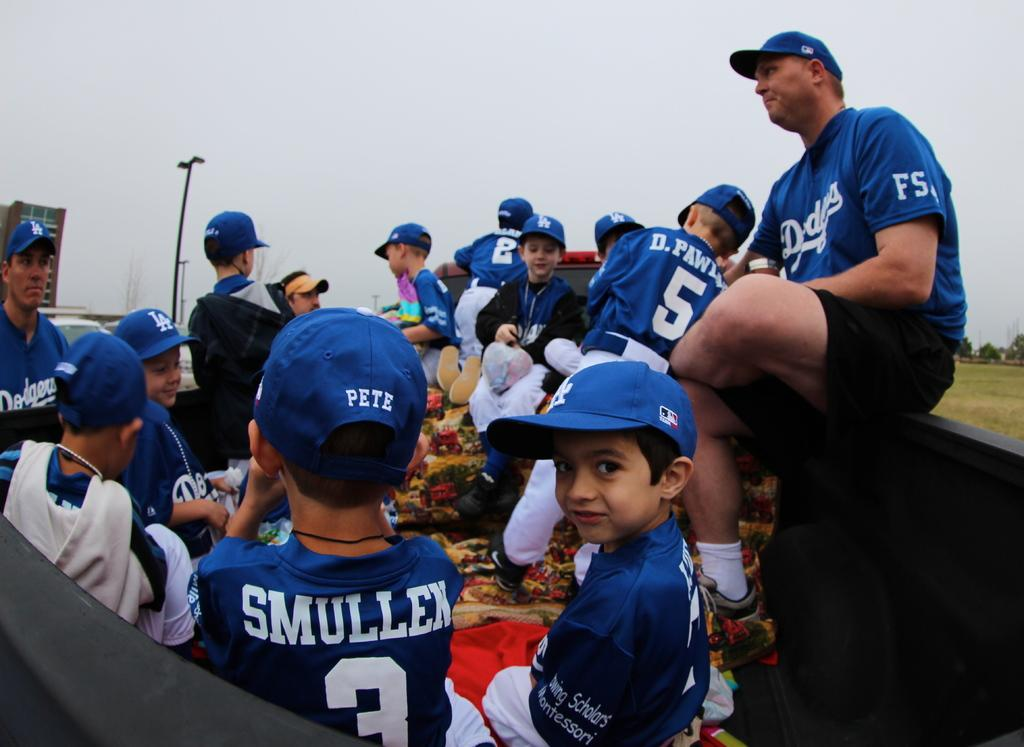Provide a one-sentence caption for the provided image. A baseball team in blue Dogers uniforms on with player number 3 looking in front of him with the name Pete on the back of his hat. 